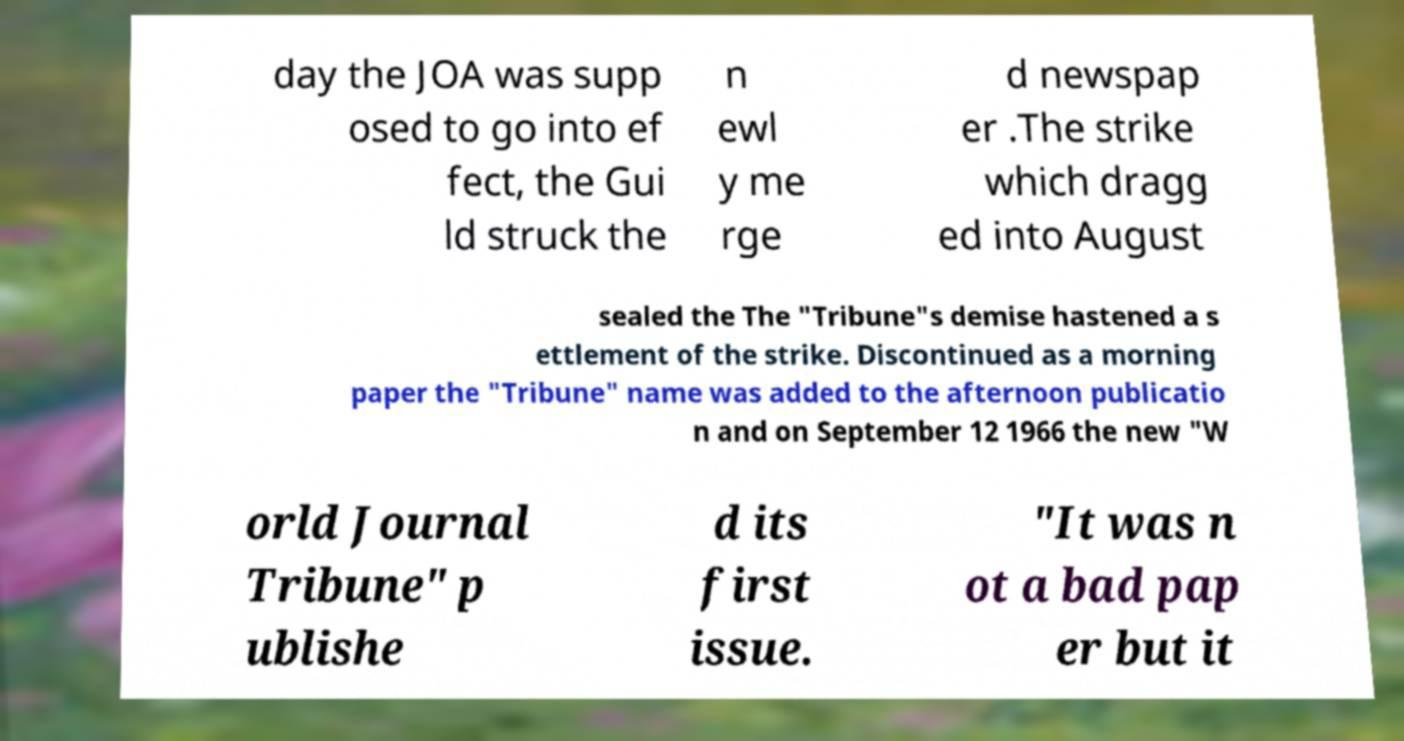What messages or text are displayed in this image? I need them in a readable, typed format. day the JOA was supp osed to go into ef fect, the Gui ld struck the n ewl y me rge d newspap er .The strike which dragg ed into August sealed the The "Tribune"s demise hastened a s ettlement of the strike. Discontinued as a morning paper the "Tribune" name was added to the afternoon publicatio n and on September 12 1966 the new "W orld Journal Tribune" p ublishe d its first issue. "It was n ot a bad pap er but it 